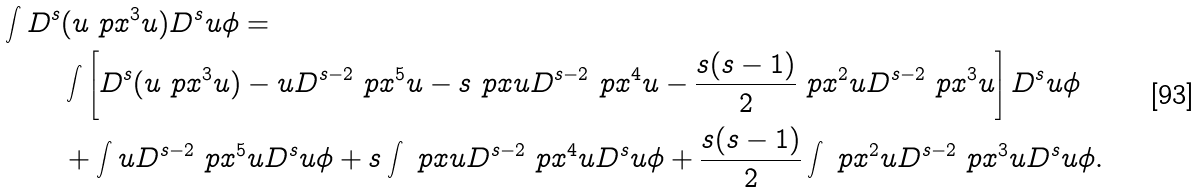<formula> <loc_0><loc_0><loc_500><loc_500>\int D ^ { s } & ( u \ p x ^ { 3 } u ) D ^ { s } u \phi = \\ & \int \left [ D ^ { s } ( u \ p x ^ { 3 } u ) - u D ^ { s - 2 } \ p x ^ { 5 } u - s \ p x u D ^ { s - 2 } \ p x ^ { 4 } u - \frac { s ( s - 1 ) } { 2 } \ p x ^ { 2 } u D ^ { s - 2 } \ p x ^ { 3 } u \right ] D ^ { s } u \phi \\ & + \int u D ^ { s - 2 } \ p x ^ { 5 } u D ^ { s } u \phi + s \int \ p x u D ^ { s - 2 } \ p x ^ { 4 } u D ^ { s } u \phi + \frac { s ( s - 1 ) } { 2 } \int \ p x ^ { 2 } u D ^ { s - 2 } \ p x ^ { 3 } u D ^ { s } u \phi .</formula> 